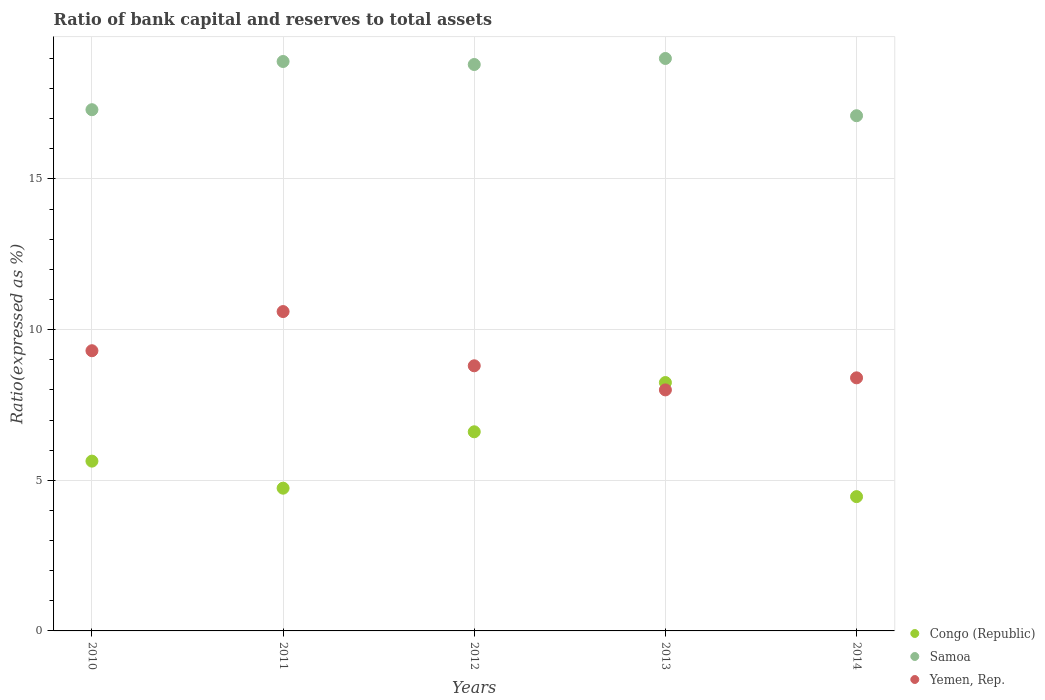How many different coloured dotlines are there?
Keep it short and to the point. 3. What is the ratio of bank capital and reserves to total assets in Congo (Republic) in 2013?
Ensure brevity in your answer.  8.24. Across all years, what is the minimum ratio of bank capital and reserves to total assets in Yemen, Rep.?
Keep it short and to the point. 8. In which year was the ratio of bank capital and reserves to total assets in Congo (Republic) minimum?
Ensure brevity in your answer.  2014. What is the total ratio of bank capital and reserves to total assets in Congo (Republic) in the graph?
Your response must be concise. 29.68. What is the difference between the ratio of bank capital and reserves to total assets in Yemen, Rep. in 2011 and that in 2014?
Make the answer very short. 2.2. What is the difference between the ratio of bank capital and reserves to total assets in Samoa in 2011 and the ratio of bank capital and reserves to total assets in Yemen, Rep. in 2012?
Keep it short and to the point. 10.1. What is the average ratio of bank capital and reserves to total assets in Yemen, Rep. per year?
Make the answer very short. 9.02. In the year 2012, what is the difference between the ratio of bank capital and reserves to total assets in Congo (Republic) and ratio of bank capital and reserves to total assets in Yemen, Rep.?
Provide a short and direct response. -2.19. What is the ratio of the ratio of bank capital and reserves to total assets in Congo (Republic) in 2012 to that in 2014?
Your answer should be compact. 1.48. Is the ratio of bank capital and reserves to total assets in Yemen, Rep. in 2012 less than that in 2014?
Keep it short and to the point. No. Is the difference between the ratio of bank capital and reserves to total assets in Congo (Republic) in 2010 and 2012 greater than the difference between the ratio of bank capital and reserves to total assets in Yemen, Rep. in 2010 and 2012?
Offer a very short reply. No. What is the difference between the highest and the second highest ratio of bank capital and reserves to total assets in Yemen, Rep.?
Offer a terse response. 1.3. What is the difference between the highest and the lowest ratio of bank capital and reserves to total assets in Samoa?
Offer a terse response. 1.9. Is the sum of the ratio of bank capital and reserves to total assets in Yemen, Rep. in 2010 and 2011 greater than the maximum ratio of bank capital and reserves to total assets in Samoa across all years?
Ensure brevity in your answer.  Yes. Is it the case that in every year, the sum of the ratio of bank capital and reserves to total assets in Yemen, Rep. and ratio of bank capital and reserves to total assets in Congo (Republic)  is greater than the ratio of bank capital and reserves to total assets in Samoa?
Keep it short and to the point. No. Does the ratio of bank capital and reserves to total assets in Yemen, Rep. monotonically increase over the years?
Give a very brief answer. No. Is the ratio of bank capital and reserves to total assets in Yemen, Rep. strictly less than the ratio of bank capital and reserves to total assets in Congo (Republic) over the years?
Offer a very short reply. No. What is the difference between two consecutive major ticks on the Y-axis?
Your answer should be compact. 5. Are the values on the major ticks of Y-axis written in scientific E-notation?
Provide a short and direct response. No. Does the graph contain any zero values?
Ensure brevity in your answer.  No. How are the legend labels stacked?
Provide a short and direct response. Vertical. What is the title of the graph?
Keep it short and to the point. Ratio of bank capital and reserves to total assets. What is the label or title of the Y-axis?
Your response must be concise. Ratio(expressed as %). What is the Ratio(expressed as %) in Congo (Republic) in 2010?
Offer a very short reply. 5.64. What is the Ratio(expressed as %) of Yemen, Rep. in 2010?
Keep it short and to the point. 9.3. What is the Ratio(expressed as %) of Congo (Republic) in 2011?
Offer a terse response. 4.74. What is the Ratio(expressed as %) of Yemen, Rep. in 2011?
Offer a terse response. 10.6. What is the Ratio(expressed as %) of Congo (Republic) in 2012?
Provide a short and direct response. 6.61. What is the Ratio(expressed as %) in Samoa in 2012?
Your answer should be compact. 18.8. What is the Ratio(expressed as %) of Congo (Republic) in 2013?
Give a very brief answer. 8.24. What is the Ratio(expressed as %) in Samoa in 2013?
Provide a short and direct response. 19. What is the Ratio(expressed as %) in Yemen, Rep. in 2013?
Give a very brief answer. 8. What is the Ratio(expressed as %) in Congo (Republic) in 2014?
Ensure brevity in your answer.  4.46. What is the Ratio(expressed as %) of Yemen, Rep. in 2014?
Ensure brevity in your answer.  8.4. Across all years, what is the maximum Ratio(expressed as %) of Congo (Republic)?
Provide a short and direct response. 8.24. Across all years, what is the maximum Ratio(expressed as %) in Samoa?
Ensure brevity in your answer.  19. Across all years, what is the maximum Ratio(expressed as %) in Yemen, Rep.?
Provide a succinct answer. 10.6. Across all years, what is the minimum Ratio(expressed as %) of Congo (Republic)?
Your response must be concise. 4.46. Across all years, what is the minimum Ratio(expressed as %) of Yemen, Rep.?
Offer a very short reply. 8. What is the total Ratio(expressed as %) in Congo (Republic) in the graph?
Your answer should be compact. 29.68. What is the total Ratio(expressed as %) in Samoa in the graph?
Make the answer very short. 91.1. What is the total Ratio(expressed as %) in Yemen, Rep. in the graph?
Your answer should be very brief. 45.1. What is the difference between the Ratio(expressed as %) in Congo (Republic) in 2010 and that in 2011?
Your response must be concise. 0.9. What is the difference between the Ratio(expressed as %) in Yemen, Rep. in 2010 and that in 2011?
Provide a succinct answer. -1.3. What is the difference between the Ratio(expressed as %) in Congo (Republic) in 2010 and that in 2012?
Offer a terse response. -0.97. What is the difference between the Ratio(expressed as %) of Congo (Republic) in 2010 and that in 2013?
Your answer should be very brief. -2.61. What is the difference between the Ratio(expressed as %) in Congo (Republic) in 2010 and that in 2014?
Ensure brevity in your answer.  1.18. What is the difference between the Ratio(expressed as %) in Congo (Republic) in 2011 and that in 2012?
Ensure brevity in your answer.  -1.87. What is the difference between the Ratio(expressed as %) in Yemen, Rep. in 2011 and that in 2012?
Give a very brief answer. 1.8. What is the difference between the Ratio(expressed as %) of Congo (Republic) in 2011 and that in 2013?
Provide a succinct answer. -3.51. What is the difference between the Ratio(expressed as %) of Samoa in 2011 and that in 2013?
Give a very brief answer. -0.1. What is the difference between the Ratio(expressed as %) in Congo (Republic) in 2011 and that in 2014?
Provide a short and direct response. 0.28. What is the difference between the Ratio(expressed as %) in Samoa in 2011 and that in 2014?
Your answer should be very brief. 1.8. What is the difference between the Ratio(expressed as %) in Yemen, Rep. in 2011 and that in 2014?
Offer a very short reply. 2.2. What is the difference between the Ratio(expressed as %) in Congo (Republic) in 2012 and that in 2013?
Your response must be concise. -1.63. What is the difference between the Ratio(expressed as %) in Yemen, Rep. in 2012 and that in 2013?
Provide a short and direct response. 0.8. What is the difference between the Ratio(expressed as %) in Congo (Republic) in 2012 and that in 2014?
Your response must be concise. 2.15. What is the difference between the Ratio(expressed as %) of Congo (Republic) in 2013 and that in 2014?
Provide a succinct answer. 3.79. What is the difference between the Ratio(expressed as %) of Samoa in 2013 and that in 2014?
Give a very brief answer. 1.9. What is the difference between the Ratio(expressed as %) in Congo (Republic) in 2010 and the Ratio(expressed as %) in Samoa in 2011?
Keep it short and to the point. -13.26. What is the difference between the Ratio(expressed as %) in Congo (Republic) in 2010 and the Ratio(expressed as %) in Yemen, Rep. in 2011?
Offer a terse response. -4.96. What is the difference between the Ratio(expressed as %) in Samoa in 2010 and the Ratio(expressed as %) in Yemen, Rep. in 2011?
Provide a succinct answer. 6.7. What is the difference between the Ratio(expressed as %) in Congo (Republic) in 2010 and the Ratio(expressed as %) in Samoa in 2012?
Your response must be concise. -13.16. What is the difference between the Ratio(expressed as %) of Congo (Republic) in 2010 and the Ratio(expressed as %) of Yemen, Rep. in 2012?
Offer a very short reply. -3.16. What is the difference between the Ratio(expressed as %) of Congo (Republic) in 2010 and the Ratio(expressed as %) of Samoa in 2013?
Your answer should be compact. -13.36. What is the difference between the Ratio(expressed as %) in Congo (Republic) in 2010 and the Ratio(expressed as %) in Yemen, Rep. in 2013?
Provide a short and direct response. -2.36. What is the difference between the Ratio(expressed as %) in Congo (Republic) in 2010 and the Ratio(expressed as %) in Samoa in 2014?
Make the answer very short. -11.46. What is the difference between the Ratio(expressed as %) of Congo (Republic) in 2010 and the Ratio(expressed as %) of Yemen, Rep. in 2014?
Ensure brevity in your answer.  -2.76. What is the difference between the Ratio(expressed as %) in Samoa in 2010 and the Ratio(expressed as %) in Yemen, Rep. in 2014?
Your answer should be very brief. 8.9. What is the difference between the Ratio(expressed as %) in Congo (Republic) in 2011 and the Ratio(expressed as %) in Samoa in 2012?
Offer a terse response. -14.06. What is the difference between the Ratio(expressed as %) in Congo (Republic) in 2011 and the Ratio(expressed as %) in Yemen, Rep. in 2012?
Make the answer very short. -4.06. What is the difference between the Ratio(expressed as %) in Congo (Republic) in 2011 and the Ratio(expressed as %) in Samoa in 2013?
Offer a very short reply. -14.26. What is the difference between the Ratio(expressed as %) of Congo (Republic) in 2011 and the Ratio(expressed as %) of Yemen, Rep. in 2013?
Ensure brevity in your answer.  -3.26. What is the difference between the Ratio(expressed as %) in Congo (Republic) in 2011 and the Ratio(expressed as %) in Samoa in 2014?
Provide a short and direct response. -12.36. What is the difference between the Ratio(expressed as %) of Congo (Republic) in 2011 and the Ratio(expressed as %) of Yemen, Rep. in 2014?
Your answer should be compact. -3.66. What is the difference between the Ratio(expressed as %) in Congo (Republic) in 2012 and the Ratio(expressed as %) in Samoa in 2013?
Your response must be concise. -12.39. What is the difference between the Ratio(expressed as %) in Congo (Republic) in 2012 and the Ratio(expressed as %) in Yemen, Rep. in 2013?
Provide a succinct answer. -1.39. What is the difference between the Ratio(expressed as %) in Congo (Republic) in 2012 and the Ratio(expressed as %) in Samoa in 2014?
Give a very brief answer. -10.49. What is the difference between the Ratio(expressed as %) of Congo (Republic) in 2012 and the Ratio(expressed as %) of Yemen, Rep. in 2014?
Offer a terse response. -1.79. What is the difference between the Ratio(expressed as %) in Samoa in 2012 and the Ratio(expressed as %) in Yemen, Rep. in 2014?
Your answer should be very brief. 10.4. What is the difference between the Ratio(expressed as %) in Congo (Republic) in 2013 and the Ratio(expressed as %) in Samoa in 2014?
Your answer should be very brief. -8.86. What is the difference between the Ratio(expressed as %) in Congo (Republic) in 2013 and the Ratio(expressed as %) in Yemen, Rep. in 2014?
Ensure brevity in your answer.  -0.16. What is the average Ratio(expressed as %) in Congo (Republic) per year?
Your answer should be very brief. 5.94. What is the average Ratio(expressed as %) of Samoa per year?
Your response must be concise. 18.22. What is the average Ratio(expressed as %) of Yemen, Rep. per year?
Your response must be concise. 9.02. In the year 2010, what is the difference between the Ratio(expressed as %) of Congo (Republic) and Ratio(expressed as %) of Samoa?
Provide a short and direct response. -11.66. In the year 2010, what is the difference between the Ratio(expressed as %) in Congo (Republic) and Ratio(expressed as %) in Yemen, Rep.?
Provide a short and direct response. -3.66. In the year 2011, what is the difference between the Ratio(expressed as %) of Congo (Republic) and Ratio(expressed as %) of Samoa?
Offer a very short reply. -14.16. In the year 2011, what is the difference between the Ratio(expressed as %) in Congo (Republic) and Ratio(expressed as %) in Yemen, Rep.?
Provide a short and direct response. -5.86. In the year 2012, what is the difference between the Ratio(expressed as %) of Congo (Republic) and Ratio(expressed as %) of Samoa?
Keep it short and to the point. -12.19. In the year 2012, what is the difference between the Ratio(expressed as %) in Congo (Republic) and Ratio(expressed as %) in Yemen, Rep.?
Provide a succinct answer. -2.19. In the year 2012, what is the difference between the Ratio(expressed as %) in Samoa and Ratio(expressed as %) in Yemen, Rep.?
Provide a short and direct response. 10. In the year 2013, what is the difference between the Ratio(expressed as %) of Congo (Republic) and Ratio(expressed as %) of Samoa?
Make the answer very short. -10.76. In the year 2013, what is the difference between the Ratio(expressed as %) in Congo (Republic) and Ratio(expressed as %) in Yemen, Rep.?
Offer a terse response. 0.24. In the year 2013, what is the difference between the Ratio(expressed as %) in Samoa and Ratio(expressed as %) in Yemen, Rep.?
Your answer should be very brief. 11. In the year 2014, what is the difference between the Ratio(expressed as %) of Congo (Republic) and Ratio(expressed as %) of Samoa?
Keep it short and to the point. -12.64. In the year 2014, what is the difference between the Ratio(expressed as %) of Congo (Republic) and Ratio(expressed as %) of Yemen, Rep.?
Provide a succinct answer. -3.94. What is the ratio of the Ratio(expressed as %) of Congo (Republic) in 2010 to that in 2011?
Offer a very short reply. 1.19. What is the ratio of the Ratio(expressed as %) in Samoa in 2010 to that in 2011?
Offer a terse response. 0.92. What is the ratio of the Ratio(expressed as %) in Yemen, Rep. in 2010 to that in 2011?
Your response must be concise. 0.88. What is the ratio of the Ratio(expressed as %) in Congo (Republic) in 2010 to that in 2012?
Your answer should be compact. 0.85. What is the ratio of the Ratio(expressed as %) in Samoa in 2010 to that in 2012?
Offer a very short reply. 0.92. What is the ratio of the Ratio(expressed as %) of Yemen, Rep. in 2010 to that in 2012?
Provide a short and direct response. 1.06. What is the ratio of the Ratio(expressed as %) in Congo (Republic) in 2010 to that in 2013?
Give a very brief answer. 0.68. What is the ratio of the Ratio(expressed as %) of Samoa in 2010 to that in 2013?
Your answer should be very brief. 0.91. What is the ratio of the Ratio(expressed as %) of Yemen, Rep. in 2010 to that in 2013?
Offer a very short reply. 1.16. What is the ratio of the Ratio(expressed as %) of Congo (Republic) in 2010 to that in 2014?
Your response must be concise. 1.26. What is the ratio of the Ratio(expressed as %) of Samoa in 2010 to that in 2014?
Provide a short and direct response. 1.01. What is the ratio of the Ratio(expressed as %) in Yemen, Rep. in 2010 to that in 2014?
Your answer should be compact. 1.11. What is the ratio of the Ratio(expressed as %) of Congo (Republic) in 2011 to that in 2012?
Offer a terse response. 0.72. What is the ratio of the Ratio(expressed as %) of Yemen, Rep. in 2011 to that in 2012?
Your answer should be very brief. 1.2. What is the ratio of the Ratio(expressed as %) of Congo (Republic) in 2011 to that in 2013?
Keep it short and to the point. 0.57. What is the ratio of the Ratio(expressed as %) in Samoa in 2011 to that in 2013?
Make the answer very short. 0.99. What is the ratio of the Ratio(expressed as %) of Yemen, Rep. in 2011 to that in 2013?
Your response must be concise. 1.32. What is the ratio of the Ratio(expressed as %) of Congo (Republic) in 2011 to that in 2014?
Provide a succinct answer. 1.06. What is the ratio of the Ratio(expressed as %) in Samoa in 2011 to that in 2014?
Your answer should be compact. 1.11. What is the ratio of the Ratio(expressed as %) of Yemen, Rep. in 2011 to that in 2014?
Your answer should be compact. 1.26. What is the ratio of the Ratio(expressed as %) of Congo (Republic) in 2012 to that in 2013?
Keep it short and to the point. 0.8. What is the ratio of the Ratio(expressed as %) in Yemen, Rep. in 2012 to that in 2013?
Give a very brief answer. 1.1. What is the ratio of the Ratio(expressed as %) in Congo (Republic) in 2012 to that in 2014?
Your response must be concise. 1.48. What is the ratio of the Ratio(expressed as %) of Samoa in 2012 to that in 2014?
Offer a very short reply. 1.1. What is the ratio of the Ratio(expressed as %) of Yemen, Rep. in 2012 to that in 2014?
Offer a very short reply. 1.05. What is the ratio of the Ratio(expressed as %) in Congo (Republic) in 2013 to that in 2014?
Offer a terse response. 1.85. What is the ratio of the Ratio(expressed as %) of Yemen, Rep. in 2013 to that in 2014?
Your response must be concise. 0.95. What is the difference between the highest and the second highest Ratio(expressed as %) of Congo (Republic)?
Provide a short and direct response. 1.63. What is the difference between the highest and the lowest Ratio(expressed as %) of Congo (Republic)?
Provide a succinct answer. 3.79. What is the difference between the highest and the lowest Ratio(expressed as %) in Yemen, Rep.?
Provide a succinct answer. 2.6. 